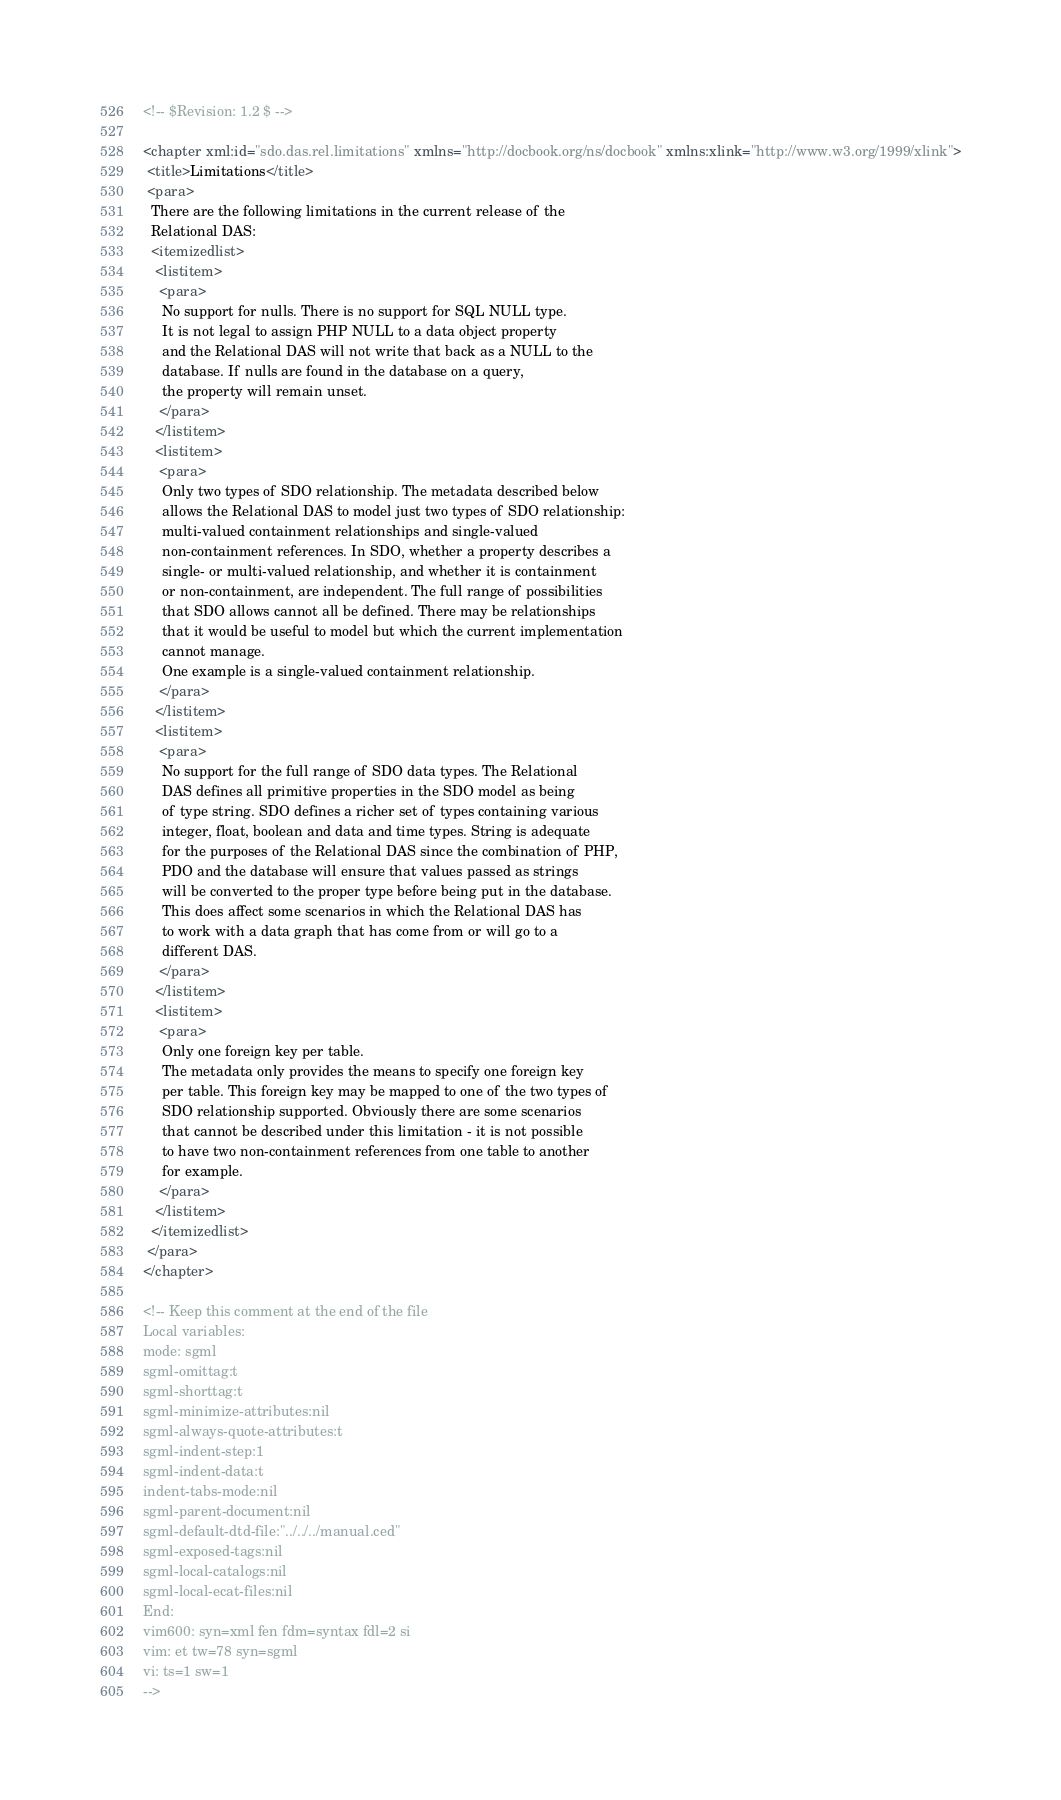Convert code to text. <code><loc_0><loc_0><loc_500><loc_500><_XML_><!-- $Revision: 1.2 $ -->

<chapter xml:id="sdo.das.rel.limitations" xmlns="http://docbook.org/ns/docbook" xmlns:xlink="http://www.w3.org/1999/xlink">
 <title>Limitations</title>
 <para>
  There are the following limitations in the current release of the 
  Relational DAS:
  <itemizedlist>
   <listitem>
    <para>
     No support for nulls. There is no support for SQL NULL type. 
     It is not legal to assign PHP NULL to a data object property
     and the Relational DAS will not write that back as a NULL to the 
     database. If nulls are found in the database on a query, 
     the property will remain unset.
    </para>
   </listitem>
   <listitem>
    <para>
     Only two types of SDO relationship. The metadata described below 
     allows the Relational DAS to model just two types of SDO relationship:
     multi-valued containment relationships and single-valued 
     non-containment references. In SDO, whether a property describes a 
     single- or multi-valued relationship, and whether it is containment 
     or non-containment, are independent. The full range of possibilities 
     that SDO allows cannot all be defined. There may be relationships 
     that it would be useful to model but which the current implementation
     cannot manage. 
     One example is a single-valued containment relationship.
    </para>
   </listitem>
   <listitem>
    <para>
     No support for the full range of SDO data types. The Relational 
     DAS defines all primitive properties in the SDO model as being 
     of type string. SDO defines a richer set of types containing various
     integer, float, boolean and data and time types. String is adequate 
     for the purposes of the Relational DAS since the combination of PHP,
     PDO and the database will ensure that values passed as strings 
     will be converted to the proper type before being put in the database.
     This does affect some scenarios in which the Relational DAS has 
     to work with a data graph that has come from or will go to a 
     different DAS.
    </para>
   </listitem>
   <listitem>
    <para>
     Only one foreign key per table. 
     The metadata only provides the means to specify one foreign key 
     per table. This foreign key may be mapped to one of the two types of 
     SDO relationship supported. Obviously there are some scenarios 
     that cannot be described under this limitation - it is not possible 
     to have two non-containment references from one table to another 
     for example.
    </para>
   </listitem>
  </itemizedlist>
 </para>
</chapter>

<!-- Keep this comment at the end of the file
Local variables:
mode: sgml
sgml-omittag:t
sgml-shorttag:t
sgml-minimize-attributes:nil
sgml-always-quote-attributes:t
sgml-indent-step:1
sgml-indent-data:t
indent-tabs-mode:nil
sgml-parent-document:nil
sgml-default-dtd-file:"../../../manual.ced"
sgml-exposed-tags:nil
sgml-local-catalogs:nil
sgml-local-ecat-files:nil
End:
vim600: syn=xml fen fdm=syntax fdl=2 si
vim: et tw=78 syn=sgml
vi: ts=1 sw=1
-->

</code> 